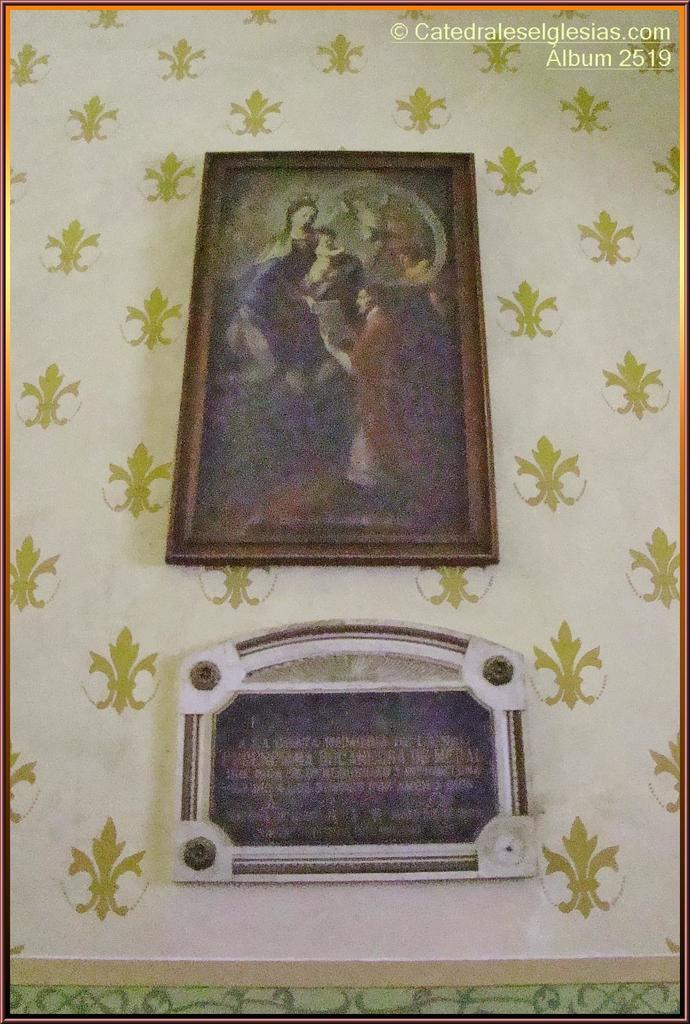How many photo frames are visible in the image? There are two photo frames in the image. Where are the photo frames located? The photo frames are attached to a wall. Can you describe the wall in the image? The wall has a design. What is present in the right top corner of the image? There is text or writing in the right top corner of the image. What place is depicted in the photo frames? The photo frames are not visible in the image, so it is impossible to determine what place they might depict. 